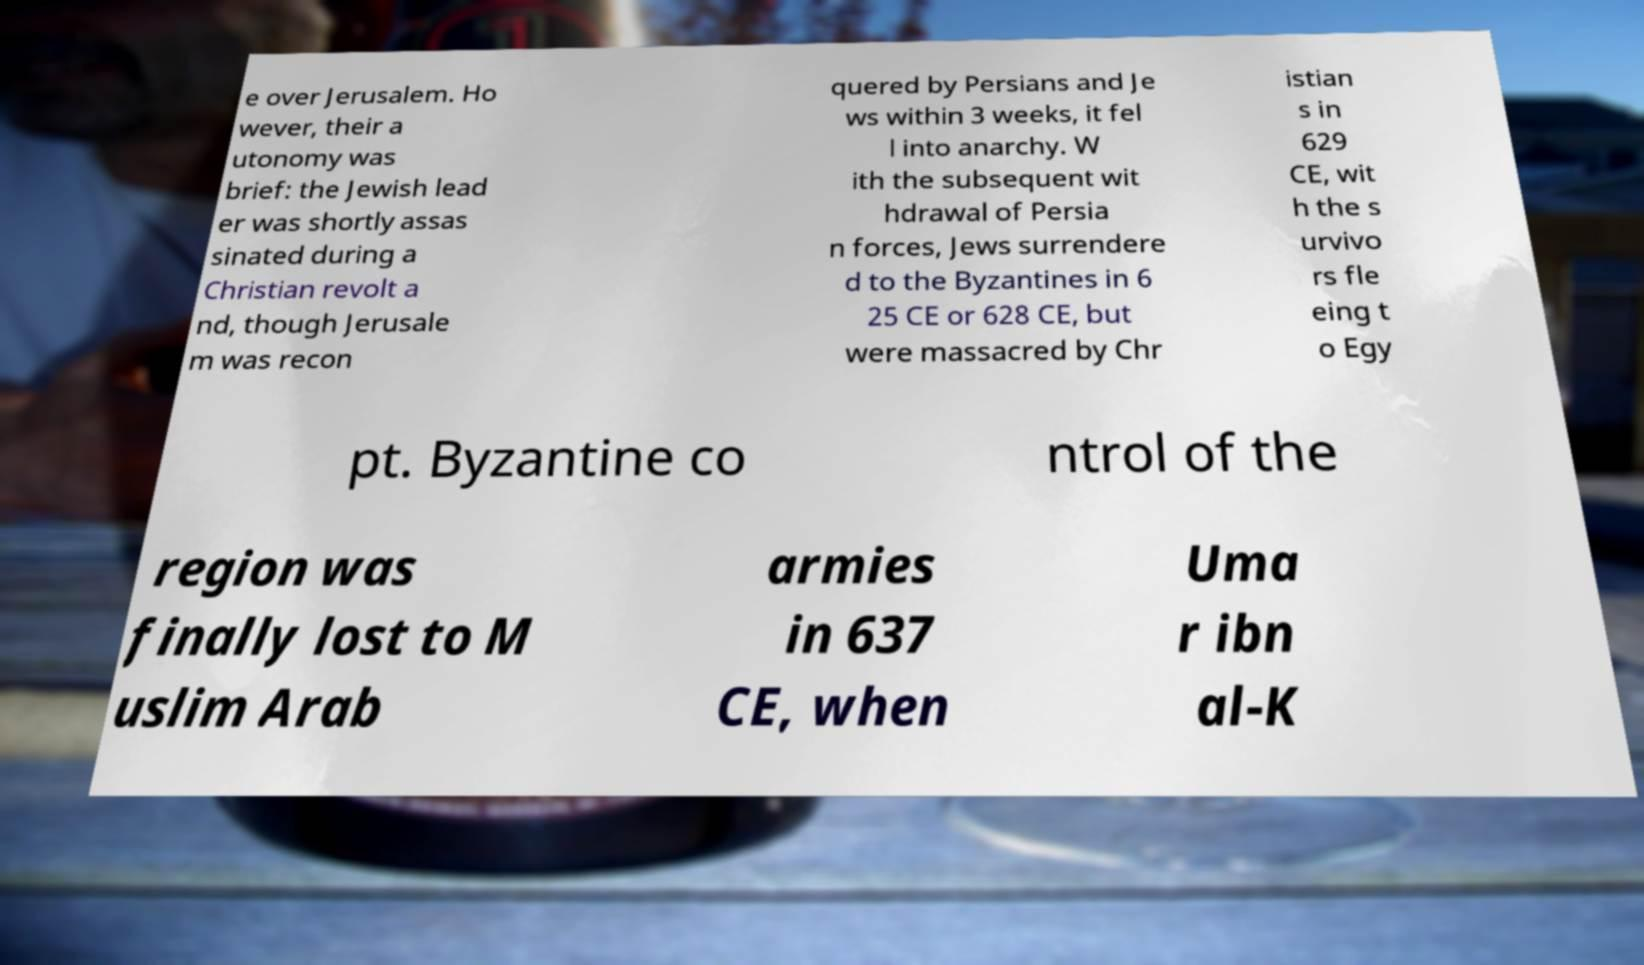Could you extract and type out the text from this image? e over Jerusalem. Ho wever, their a utonomy was brief: the Jewish lead er was shortly assas sinated during a Christian revolt a nd, though Jerusale m was recon quered by Persians and Je ws within 3 weeks, it fel l into anarchy. W ith the subsequent wit hdrawal of Persia n forces, Jews surrendere d to the Byzantines in 6 25 CE or 628 CE, but were massacred by Chr istian s in 629 CE, wit h the s urvivo rs fle eing t o Egy pt. Byzantine co ntrol of the region was finally lost to M uslim Arab armies in 637 CE, when Uma r ibn al-K 